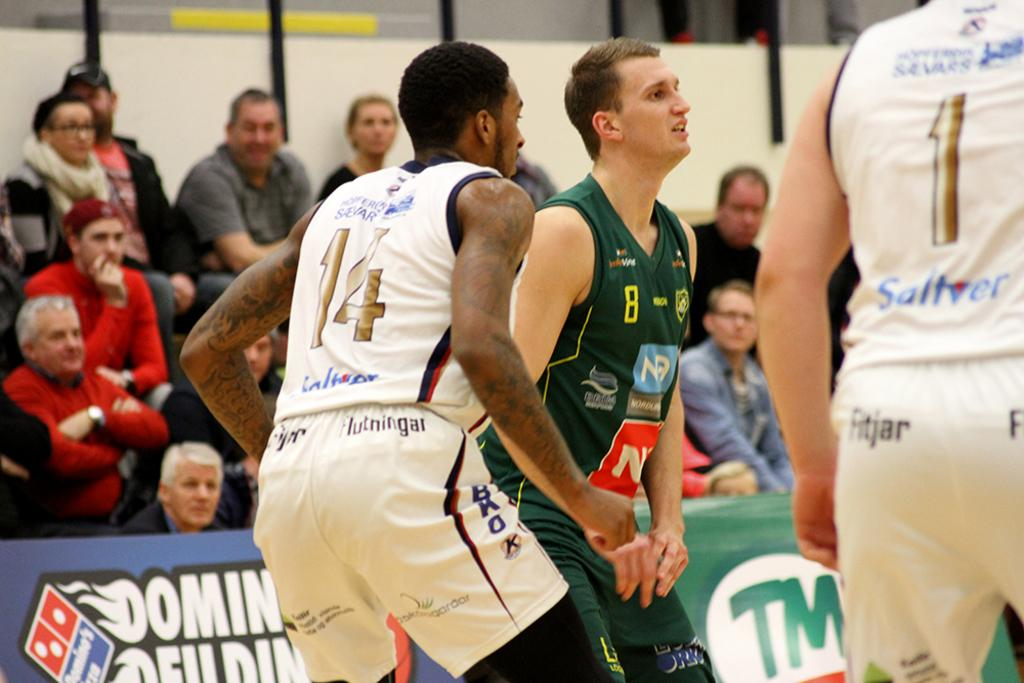<image>
Relay a brief, clear account of the picture shown. Basketball player 14 guarding number 8 who is in green. 